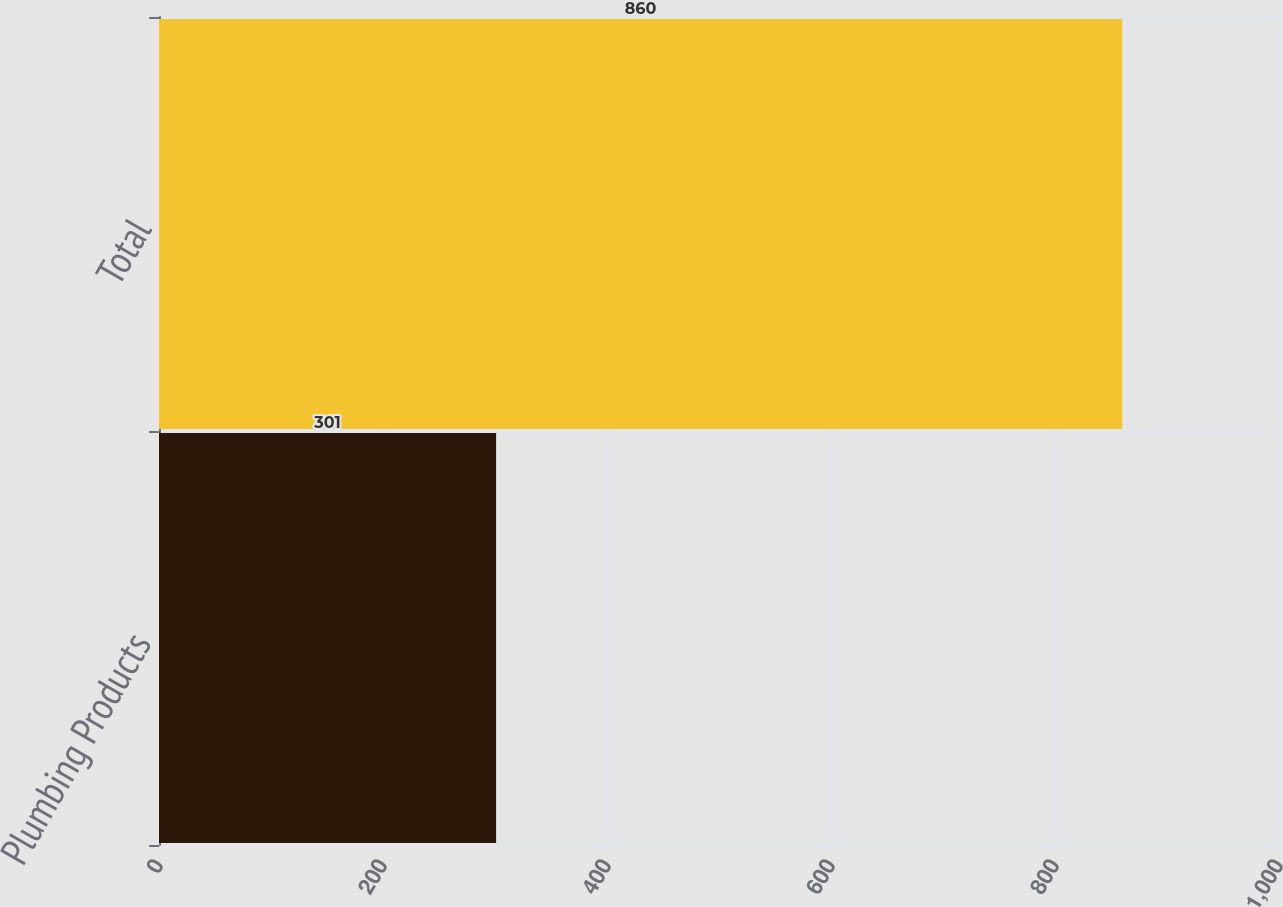Convert chart. <chart><loc_0><loc_0><loc_500><loc_500><bar_chart><fcel>Plumbing Products<fcel>Total<nl><fcel>301<fcel>860<nl></chart> 